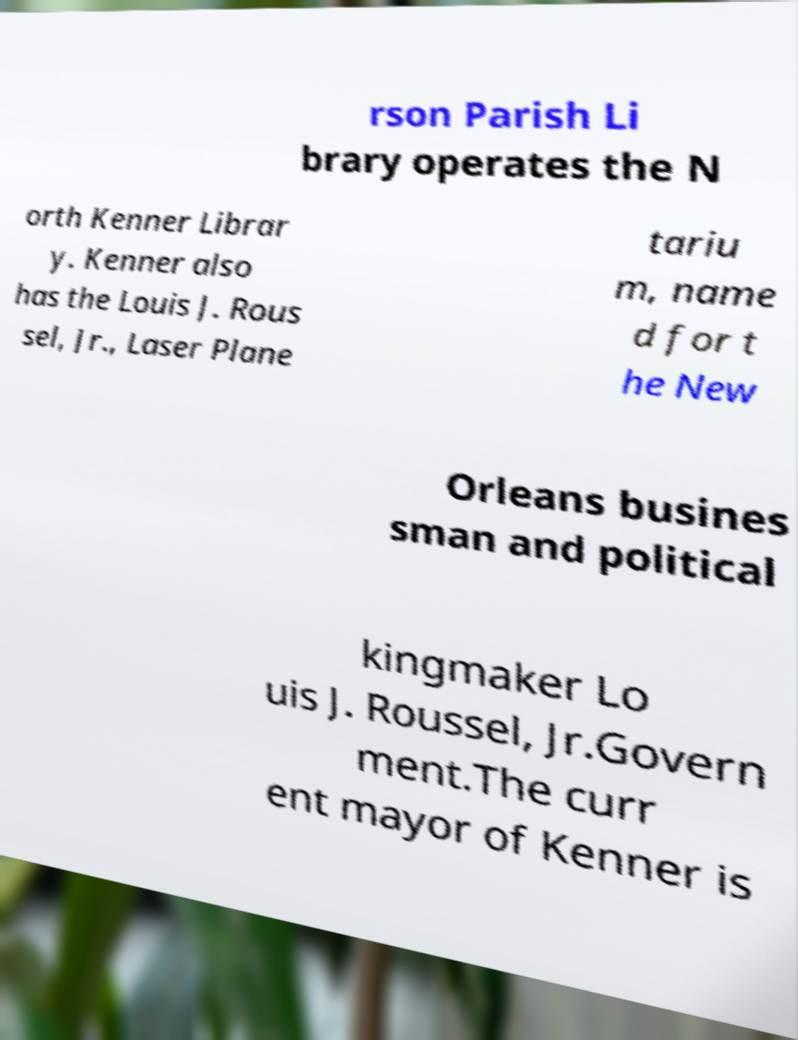Could you extract and type out the text from this image? rson Parish Li brary operates the N orth Kenner Librar y. Kenner also has the Louis J. Rous sel, Jr., Laser Plane tariu m, name d for t he New Orleans busines sman and political kingmaker Lo uis J. Roussel, Jr.Govern ment.The curr ent mayor of Kenner is 